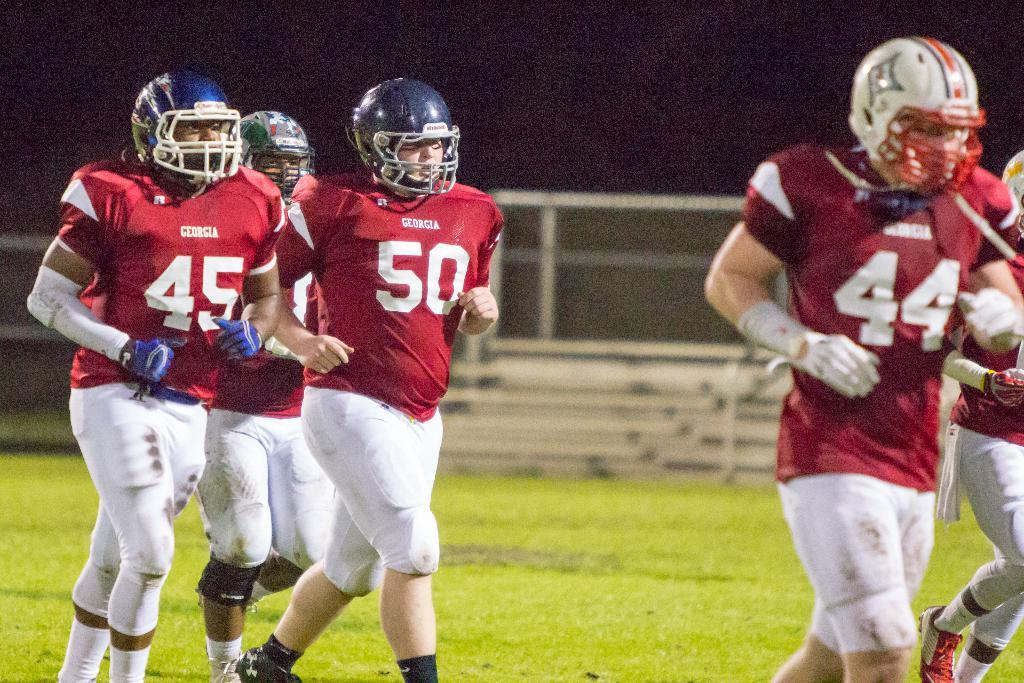What are the men in the foreground of the image doing? The men in the foreground of the image are running on a grass court. What can be seen in the background of the image? In the background of the image, there is a staircase, fencing, and grass. How would you describe the lighting in the top part of the image? The top part of the image appears to be dark. What type of receipt can be seen in the image? There is no receipt present in the image. How does the shame of the men running affect their performance in the image? There is no indication of shame or any emotional state in the image, as it only shows men running on a grass court. 